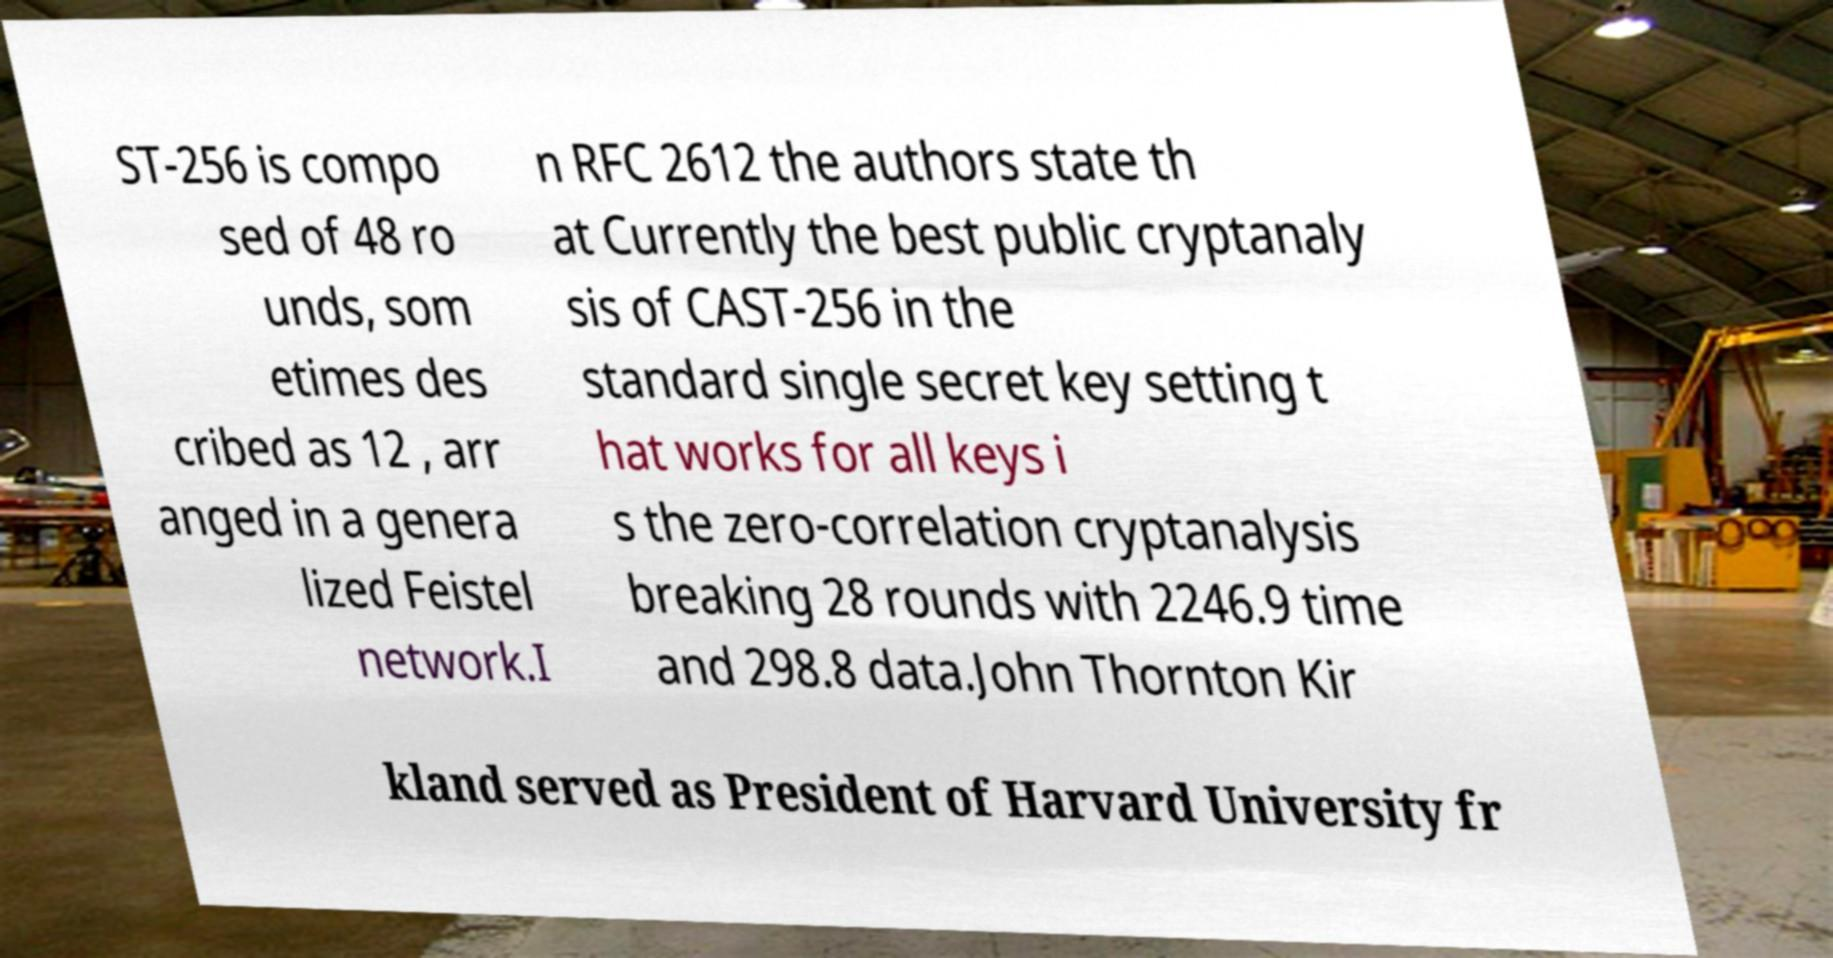Can you accurately transcribe the text from the provided image for me? ST-256 is compo sed of 48 ro unds, som etimes des cribed as 12 , arr anged in a genera lized Feistel network.I n RFC 2612 the authors state th at Currently the best public cryptanaly sis of CAST-256 in the standard single secret key setting t hat works for all keys i s the zero-correlation cryptanalysis breaking 28 rounds with 2246.9 time and 298.8 data.John Thornton Kir kland served as President of Harvard University fr 